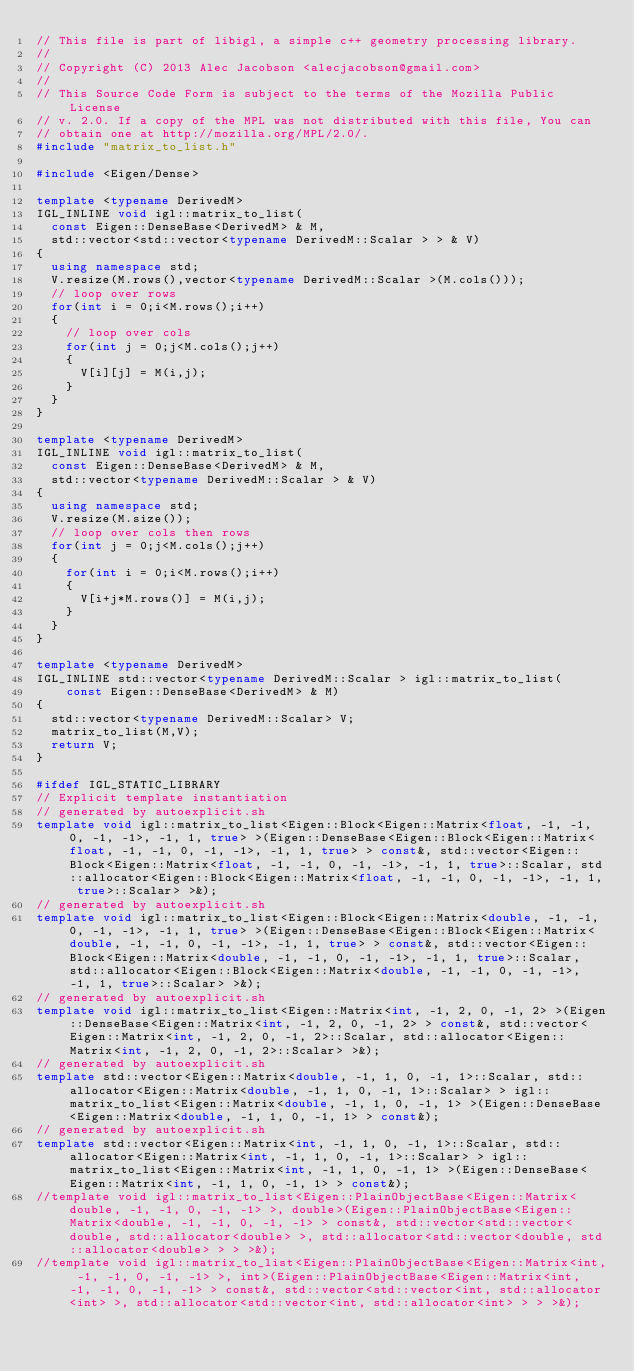<code> <loc_0><loc_0><loc_500><loc_500><_C++_>// This file is part of libigl, a simple c++ geometry processing library.
//
// Copyright (C) 2013 Alec Jacobson <alecjacobson@gmail.com>
//
// This Source Code Form is subject to the terms of the Mozilla Public License
// v. 2.0. If a copy of the MPL was not distributed with this file, You can
// obtain one at http://mozilla.org/MPL/2.0/.
#include "matrix_to_list.h"

#include <Eigen/Dense>

template <typename DerivedM>
IGL_INLINE void igl::matrix_to_list(
  const Eigen::DenseBase<DerivedM> & M,
  std::vector<std::vector<typename DerivedM::Scalar > > & V)
{
  using namespace std;
  V.resize(M.rows(),vector<typename DerivedM::Scalar >(M.cols()));
  // loop over rows
  for(int i = 0;i<M.rows();i++)
  {
    // loop over cols
    for(int j = 0;j<M.cols();j++)
    {
      V[i][j] = M(i,j);
    }
  }
}

template <typename DerivedM>
IGL_INLINE void igl::matrix_to_list(
  const Eigen::DenseBase<DerivedM> & M,
  std::vector<typename DerivedM::Scalar > & V)
{
  using namespace std;
  V.resize(M.size());
  // loop over cols then rows
  for(int j = 0;j<M.cols();j++)
  {
    for(int i = 0;i<M.rows();i++)
    {
      V[i+j*M.rows()] = M(i,j);
    }
  }
}

template <typename DerivedM>
IGL_INLINE std::vector<typename DerivedM::Scalar > igl::matrix_to_list(
    const Eigen::DenseBase<DerivedM> & M)
{
  std::vector<typename DerivedM::Scalar> V;
  matrix_to_list(M,V);
  return V;
}

#ifdef IGL_STATIC_LIBRARY
// Explicit template instantiation
// generated by autoexplicit.sh
template void igl::matrix_to_list<Eigen::Block<Eigen::Matrix<float, -1, -1, 0, -1, -1>, -1, 1, true> >(Eigen::DenseBase<Eigen::Block<Eigen::Matrix<float, -1, -1, 0, -1, -1>, -1, 1, true> > const&, std::vector<Eigen::Block<Eigen::Matrix<float, -1, -1, 0, -1, -1>, -1, 1, true>::Scalar, std::allocator<Eigen::Block<Eigen::Matrix<float, -1, -1, 0, -1, -1>, -1, 1, true>::Scalar> >&);
// generated by autoexplicit.sh
template void igl::matrix_to_list<Eigen::Block<Eigen::Matrix<double, -1, -1, 0, -1, -1>, -1, 1, true> >(Eigen::DenseBase<Eigen::Block<Eigen::Matrix<double, -1, -1, 0, -1, -1>, -1, 1, true> > const&, std::vector<Eigen::Block<Eigen::Matrix<double, -1, -1, 0, -1, -1>, -1, 1, true>::Scalar, std::allocator<Eigen::Block<Eigen::Matrix<double, -1, -1, 0, -1, -1>, -1, 1, true>::Scalar> >&);
// generated by autoexplicit.sh
template void igl::matrix_to_list<Eigen::Matrix<int, -1, 2, 0, -1, 2> >(Eigen::DenseBase<Eigen::Matrix<int, -1, 2, 0, -1, 2> > const&, std::vector<Eigen::Matrix<int, -1, 2, 0, -1, 2>::Scalar, std::allocator<Eigen::Matrix<int, -1, 2, 0, -1, 2>::Scalar> >&);
// generated by autoexplicit.sh
template std::vector<Eigen::Matrix<double, -1, 1, 0, -1, 1>::Scalar, std::allocator<Eigen::Matrix<double, -1, 1, 0, -1, 1>::Scalar> > igl::matrix_to_list<Eigen::Matrix<double, -1, 1, 0, -1, 1> >(Eigen::DenseBase<Eigen::Matrix<double, -1, 1, 0, -1, 1> > const&);
// generated by autoexplicit.sh
template std::vector<Eigen::Matrix<int, -1, 1, 0, -1, 1>::Scalar, std::allocator<Eigen::Matrix<int, -1, 1, 0, -1, 1>::Scalar> > igl::matrix_to_list<Eigen::Matrix<int, -1, 1, 0, -1, 1> >(Eigen::DenseBase<Eigen::Matrix<int, -1, 1, 0, -1, 1> > const&);
//template void igl::matrix_to_list<Eigen::PlainObjectBase<Eigen::Matrix<double, -1, -1, 0, -1, -1> >, double>(Eigen::PlainObjectBase<Eigen::Matrix<double, -1, -1, 0, -1, -1> > const&, std::vector<std::vector<double, std::allocator<double> >, std::allocator<std::vector<double, std::allocator<double> > > >&);
//template void igl::matrix_to_list<Eigen::PlainObjectBase<Eigen::Matrix<int, -1, -1, 0, -1, -1> >, int>(Eigen::PlainObjectBase<Eigen::Matrix<int, -1, -1, 0, -1, -1> > const&, std::vector<std::vector<int, std::allocator<int> >, std::allocator<std::vector<int, std::allocator<int> > > >&);</code> 